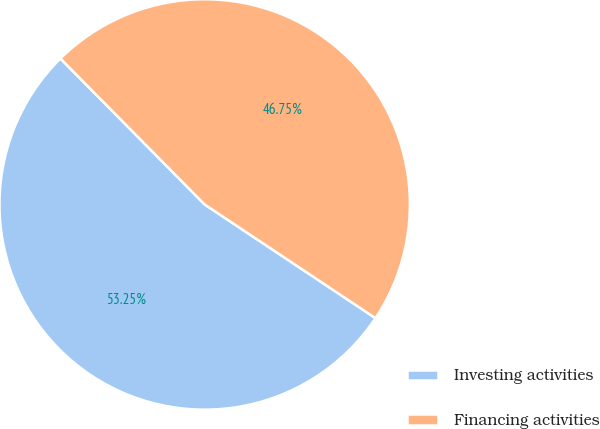Convert chart to OTSL. <chart><loc_0><loc_0><loc_500><loc_500><pie_chart><fcel>Investing activities<fcel>Financing activities<nl><fcel>53.25%<fcel>46.75%<nl></chart> 